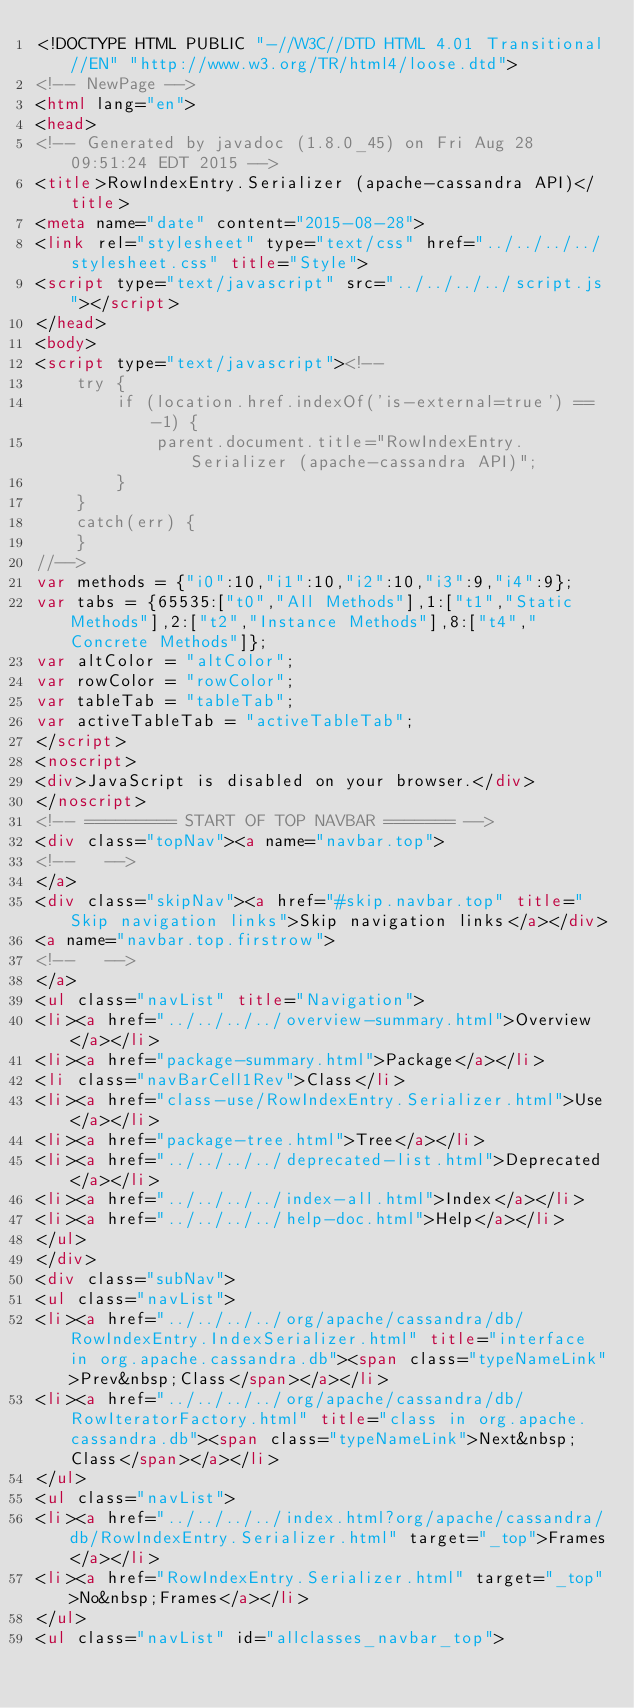Convert code to text. <code><loc_0><loc_0><loc_500><loc_500><_HTML_><!DOCTYPE HTML PUBLIC "-//W3C//DTD HTML 4.01 Transitional//EN" "http://www.w3.org/TR/html4/loose.dtd">
<!-- NewPage -->
<html lang="en">
<head>
<!-- Generated by javadoc (1.8.0_45) on Fri Aug 28 09:51:24 EDT 2015 -->
<title>RowIndexEntry.Serializer (apache-cassandra API)</title>
<meta name="date" content="2015-08-28">
<link rel="stylesheet" type="text/css" href="../../../../stylesheet.css" title="Style">
<script type="text/javascript" src="../../../../script.js"></script>
</head>
<body>
<script type="text/javascript"><!--
    try {
        if (location.href.indexOf('is-external=true') == -1) {
            parent.document.title="RowIndexEntry.Serializer (apache-cassandra API)";
        }
    }
    catch(err) {
    }
//-->
var methods = {"i0":10,"i1":10,"i2":10,"i3":9,"i4":9};
var tabs = {65535:["t0","All Methods"],1:["t1","Static Methods"],2:["t2","Instance Methods"],8:["t4","Concrete Methods"]};
var altColor = "altColor";
var rowColor = "rowColor";
var tableTab = "tableTab";
var activeTableTab = "activeTableTab";
</script>
<noscript>
<div>JavaScript is disabled on your browser.</div>
</noscript>
<!-- ========= START OF TOP NAVBAR ======= -->
<div class="topNav"><a name="navbar.top">
<!--   -->
</a>
<div class="skipNav"><a href="#skip.navbar.top" title="Skip navigation links">Skip navigation links</a></div>
<a name="navbar.top.firstrow">
<!--   -->
</a>
<ul class="navList" title="Navigation">
<li><a href="../../../../overview-summary.html">Overview</a></li>
<li><a href="package-summary.html">Package</a></li>
<li class="navBarCell1Rev">Class</li>
<li><a href="class-use/RowIndexEntry.Serializer.html">Use</a></li>
<li><a href="package-tree.html">Tree</a></li>
<li><a href="../../../../deprecated-list.html">Deprecated</a></li>
<li><a href="../../../../index-all.html">Index</a></li>
<li><a href="../../../../help-doc.html">Help</a></li>
</ul>
</div>
<div class="subNav">
<ul class="navList">
<li><a href="../../../../org/apache/cassandra/db/RowIndexEntry.IndexSerializer.html" title="interface in org.apache.cassandra.db"><span class="typeNameLink">Prev&nbsp;Class</span></a></li>
<li><a href="../../../../org/apache/cassandra/db/RowIteratorFactory.html" title="class in org.apache.cassandra.db"><span class="typeNameLink">Next&nbsp;Class</span></a></li>
</ul>
<ul class="navList">
<li><a href="../../../../index.html?org/apache/cassandra/db/RowIndexEntry.Serializer.html" target="_top">Frames</a></li>
<li><a href="RowIndexEntry.Serializer.html" target="_top">No&nbsp;Frames</a></li>
</ul>
<ul class="navList" id="allclasses_navbar_top"></code> 